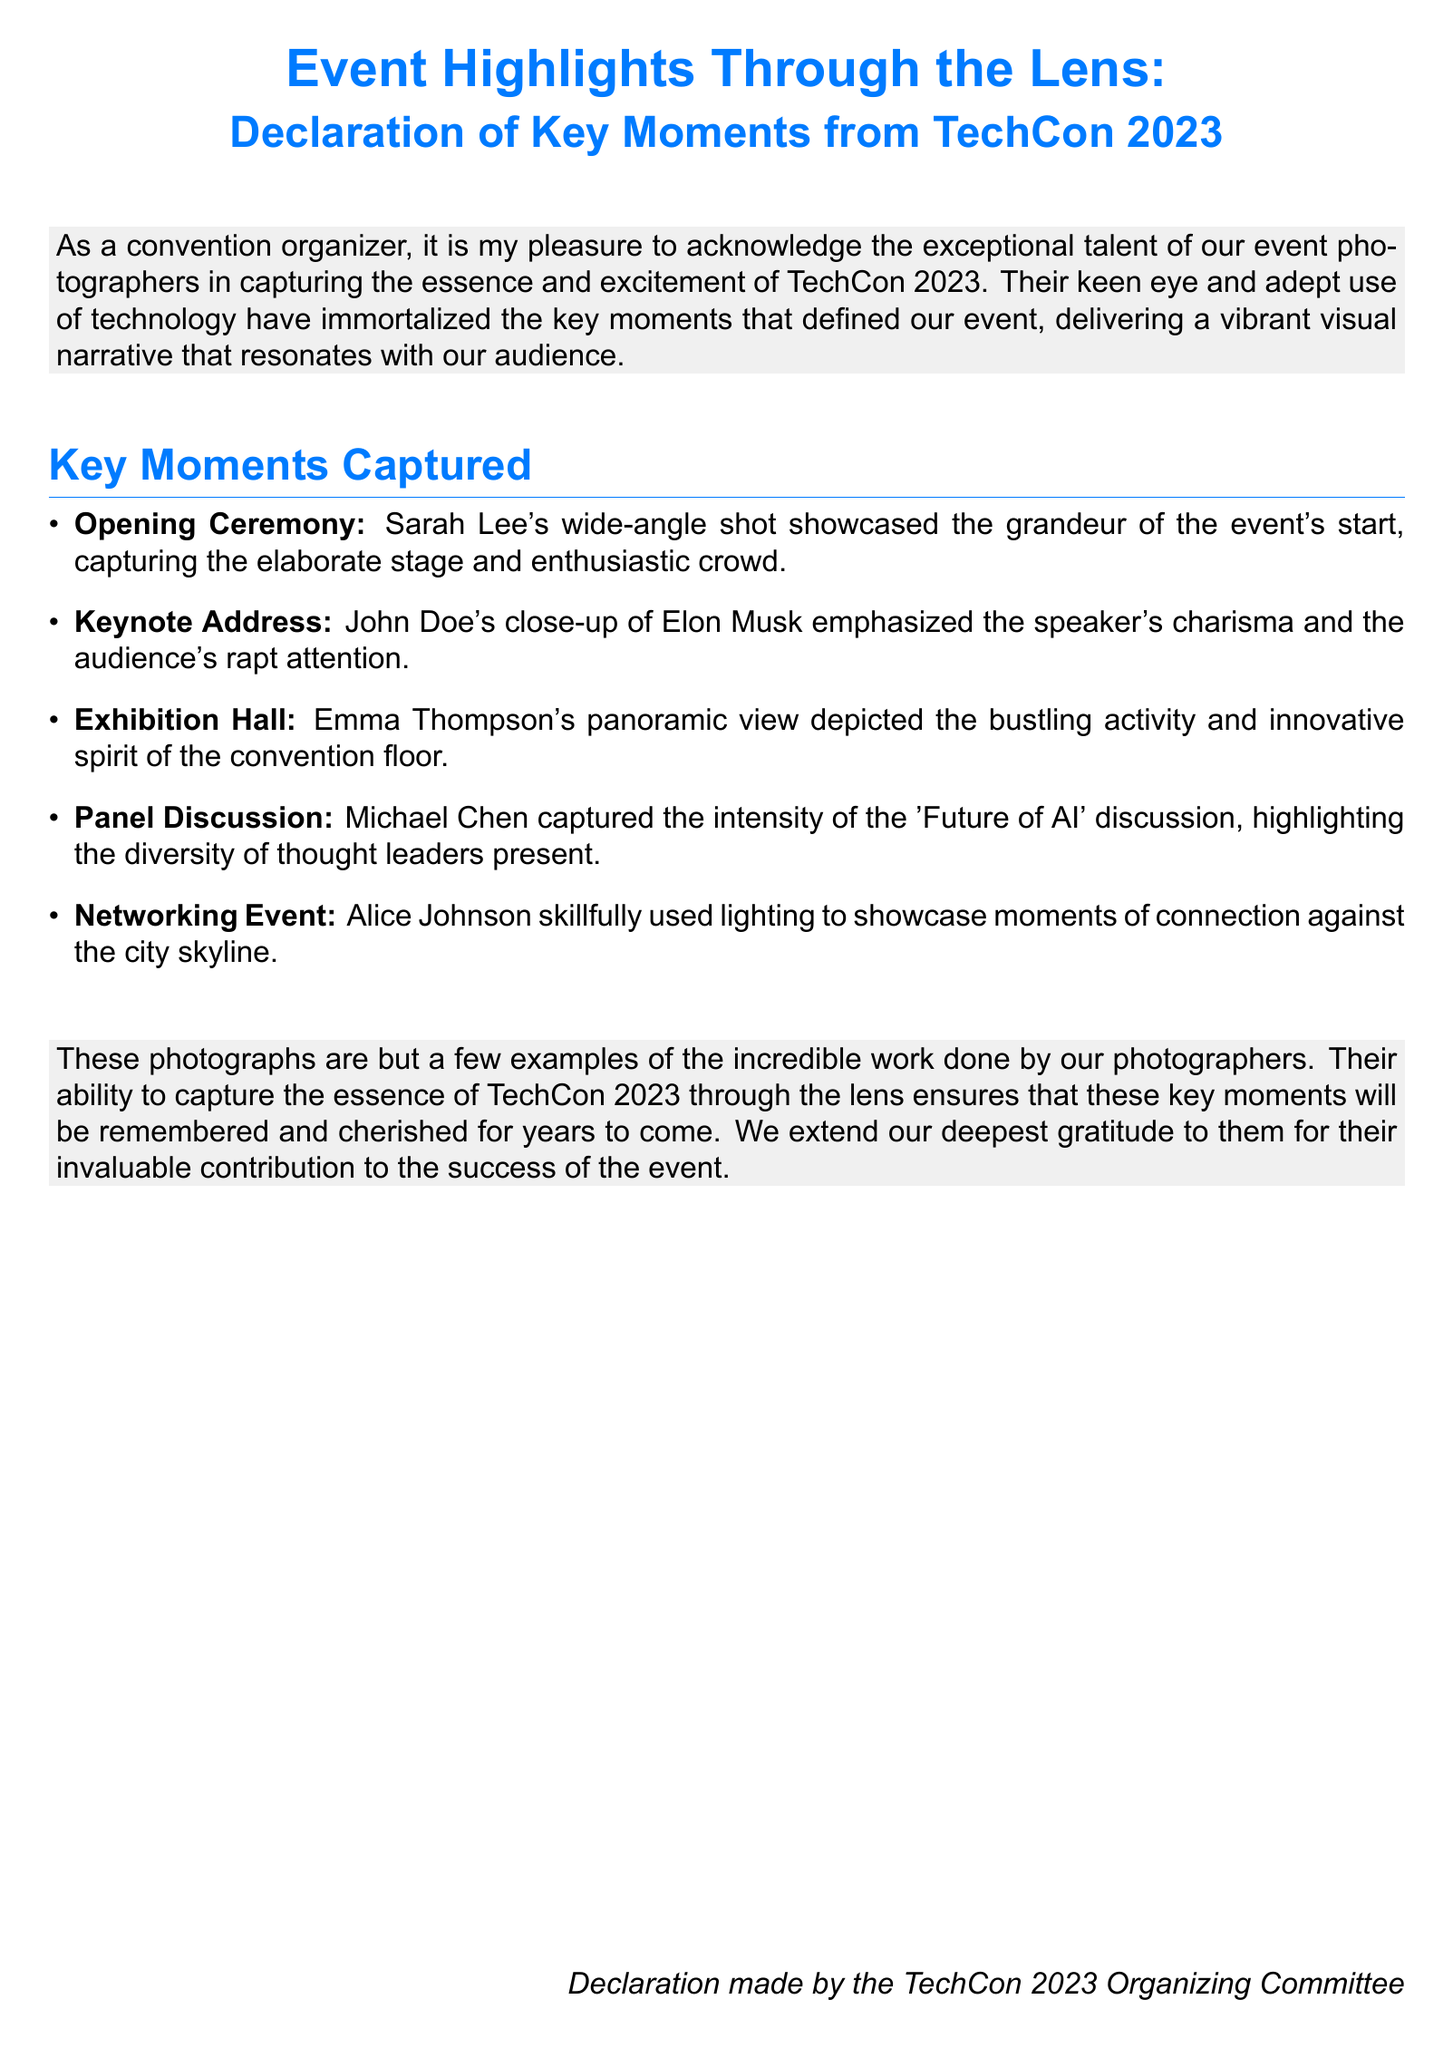What was the name of the event? The document explicitly states that the event is TechCon 2023.
Answer: TechCon 2023 Who took the wide-angle shot of the opening ceremony? The document mentions that Sarah Lee captured the grandeur of the event's start.
Answer: Sarah Lee What moment did John Doe capture? John Doe's close-up of Elon Musk during the keynote address is highlighted in the document.
Answer: Keynote Address What was the theme of the panel discussion? The document specifies that the panel discussion was about the 'Future of AI'.
Answer: Future of AI What type of shot did Alice Johnson use at the networking event? The document notes that Alice Johnson skillfully used lighting.
Answer: Lighting How many key moments are captured in the document? The document lists a total of five key moments in the itemized section.
Answer: Five What color is used for the main title? The document states that the main title is in the color techblue.
Answer: techblue Who expressed gratitude to the photographers? The text indicates that gratitude was extended by the TechCon 2023 Organizing Committee.
Answer: TechCon 2023 Organizing Committee 